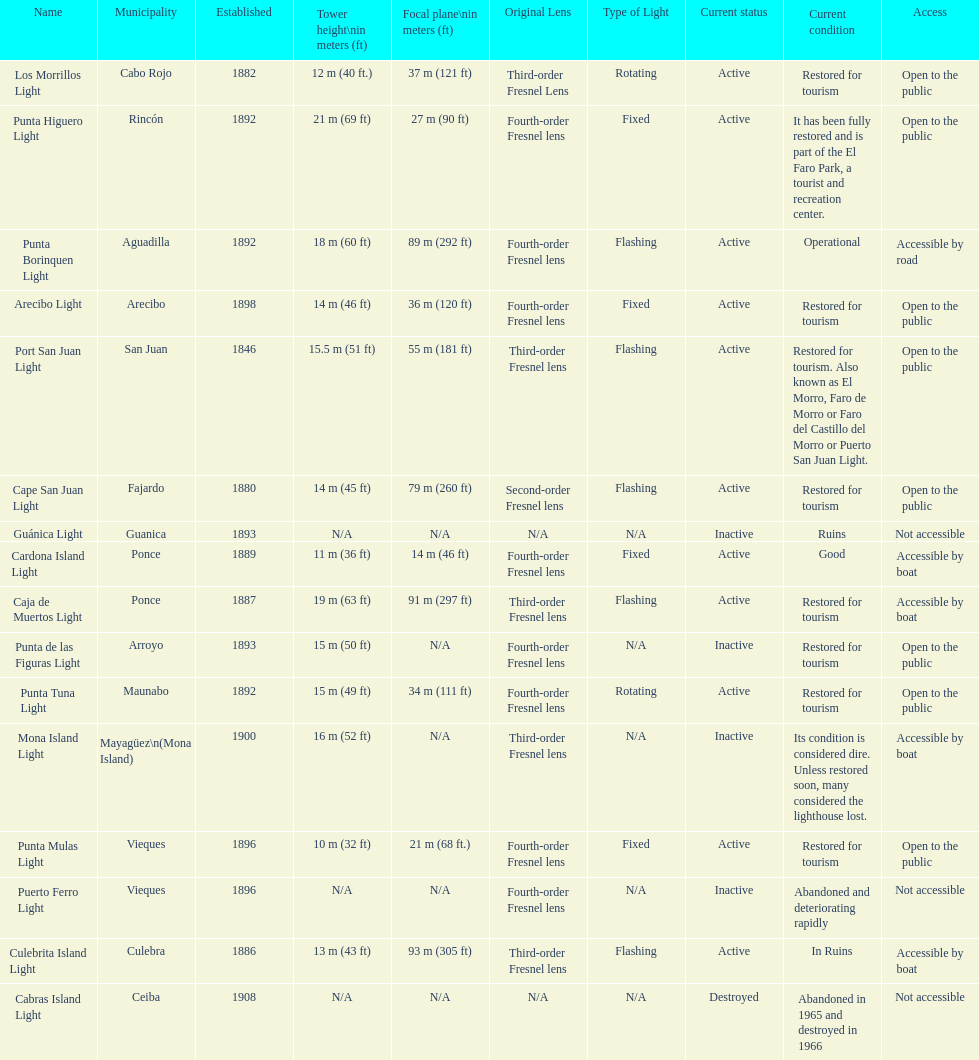Would you mind parsing the complete table? {'header': ['Name', 'Municipality', 'Established', 'Tower height\\nin meters (ft)', 'Focal plane\\nin meters (ft)', 'Original Lens', 'Type of Light', 'Current status', 'Current condition', 'Access'], 'rows': [['Los Morrillos Light', 'Cabo Rojo', '1882', '12\xa0m (40\xa0ft.)', '37\xa0m (121\xa0ft)', 'Third-order Fresnel Lens', 'Rotating', 'Active', 'Restored for tourism', 'Open to the public'], ['Punta Higuero Light', 'Rincón', '1892', '21\xa0m (69\xa0ft)', '27\xa0m (90\xa0ft)', 'Fourth-order Fresnel lens', 'Fixed', 'Active', 'It has been fully restored and is part of the El Faro Park, a tourist and recreation center.', 'Open to the public'], ['Punta Borinquen Light', 'Aguadilla', '1892', '18\xa0m (60\xa0ft)', '89\xa0m (292\xa0ft)', 'Fourth-order Fresnel lens', 'Flashing', 'Active', 'Operational', 'Accessible by road'], ['Arecibo Light', 'Arecibo', '1898', '14\xa0m (46\xa0ft)', '36\xa0m (120\xa0ft)', 'Fourth-order Fresnel lens', 'Fixed', 'Active', 'Restored for tourism', 'Open to the public'], ['Port San Juan Light', 'San Juan', '1846', '15.5\xa0m (51\xa0ft)', '55\xa0m (181\xa0ft)', 'Third-order Fresnel lens', 'Flashing', 'Active', 'Restored for tourism. Also known as El Morro, Faro de Morro or Faro del Castillo del Morro or Puerto San Juan Light.', 'Open to the public'], ['Cape San Juan Light', 'Fajardo', '1880', '14\xa0m (45\xa0ft)', '79\xa0m (260\xa0ft)', 'Second-order Fresnel lens', 'Flashing', 'Active', 'Restored for tourism', 'Open to the public'], ['Guánica Light', 'Guanica', '1893', 'N/A', 'N/A', 'N/A', 'N/A', 'Inactive', 'Ruins', 'Not accessible'], ['Cardona Island Light', 'Ponce', '1889', '11\xa0m (36\xa0ft)', '14\xa0m (46\xa0ft)', 'Fourth-order Fresnel lens', 'Fixed', 'Active', 'Good', 'Accessible by boat'], ['Caja de Muertos Light', 'Ponce', '1887', '19\xa0m (63\xa0ft)', '91\xa0m (297\xa0ft)', 'Third-order Fresnel lens', 'Flashing', 'Active', 'Restored for tourism', 'Accessible by boat'], ['Punta de las Figuras Light', 'Arroyo', '1893', '15\xa0m (50\xa0ft)', 'N/A', 'Fourth-order Fresnel lens', 'N/A', 'Inactive', 'Restored for tourism', 'Open to the public'], ['Punta Tuna Light', 'Maunabo', '1892', '15\xa0m (49\xa0ft)', '34\xa0m (111\xa0ft)', 'Fourth-order Fresnel lens', 'Rotating', 'Active', 'Restored for tourism', 'Open to the public'], ['Mona Island Light', 'Mayagüez\\n(Mona Island)', '1900', '16\xa0m (52\xa0ft)', 'N/A', 'Third-order Fresnel lens', 'N/A', 'Inactive', 'Its condition is considered dire. Unless restored soon, many considered the lighthouse lost.', 'Accessible by boat'], ['Punta Mulas Light', 'Vieques', '1896', '10\xa0m (32\xa0ft)', '21\xa0m (68\xa0ft.)', 'Fourth-order Fresnel lens', 'Fixed', 'Active', 'Restored for tourism', 'Open to the public'], ['Puerto Ferro Light', 'Vieques', '1896', 'N/A', 'N/A', 'Fourth-order Fresnel lens', 'N/A', 'Inactive', 'Abandoned and deteriorating rapidly', 'Not accessible'], ['Culebrita Island Light', 'Culebra', '1886', '13\xa0m (43\xa0ft)', '93\xa0m (305\xa0ft)', 'Third-order Fresnel lens', 'Flashing', 'Active', 'In Ruins', 'Accessible by boat'], ['Cabras Island Light', 'Ceiba', '1908', 'N/A', 'N/A', 'N/A', 'N/A', 'Destroyed', 'Abandoned in 1965 and destroyed in 1966', 'Not accessible']]} What is the largest tower Punta Higuero Light. 